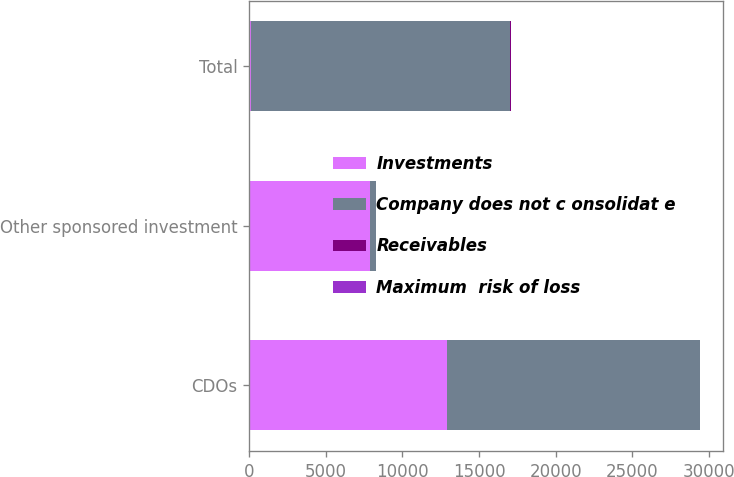<chart> <loc_0><loc_0><loc_500><loc_500><stacked_bar_chart><ecel><fcel>CDOs<fcel>Other sponsored investment<fcel>Total<nl><fcel>Investments<fcel>12891<fcel>7896<fcel>112<nl><fcel>Company does not c onsolidat e<fcel>16516<fcel>363<fcel>16879<nl><fcel>Receivables<fcel>11<fcel>13<fcel>112<nl><fcel>Maximum  risk of loss<fcel>8<fcel>5<fcel>13<nl></chart> 